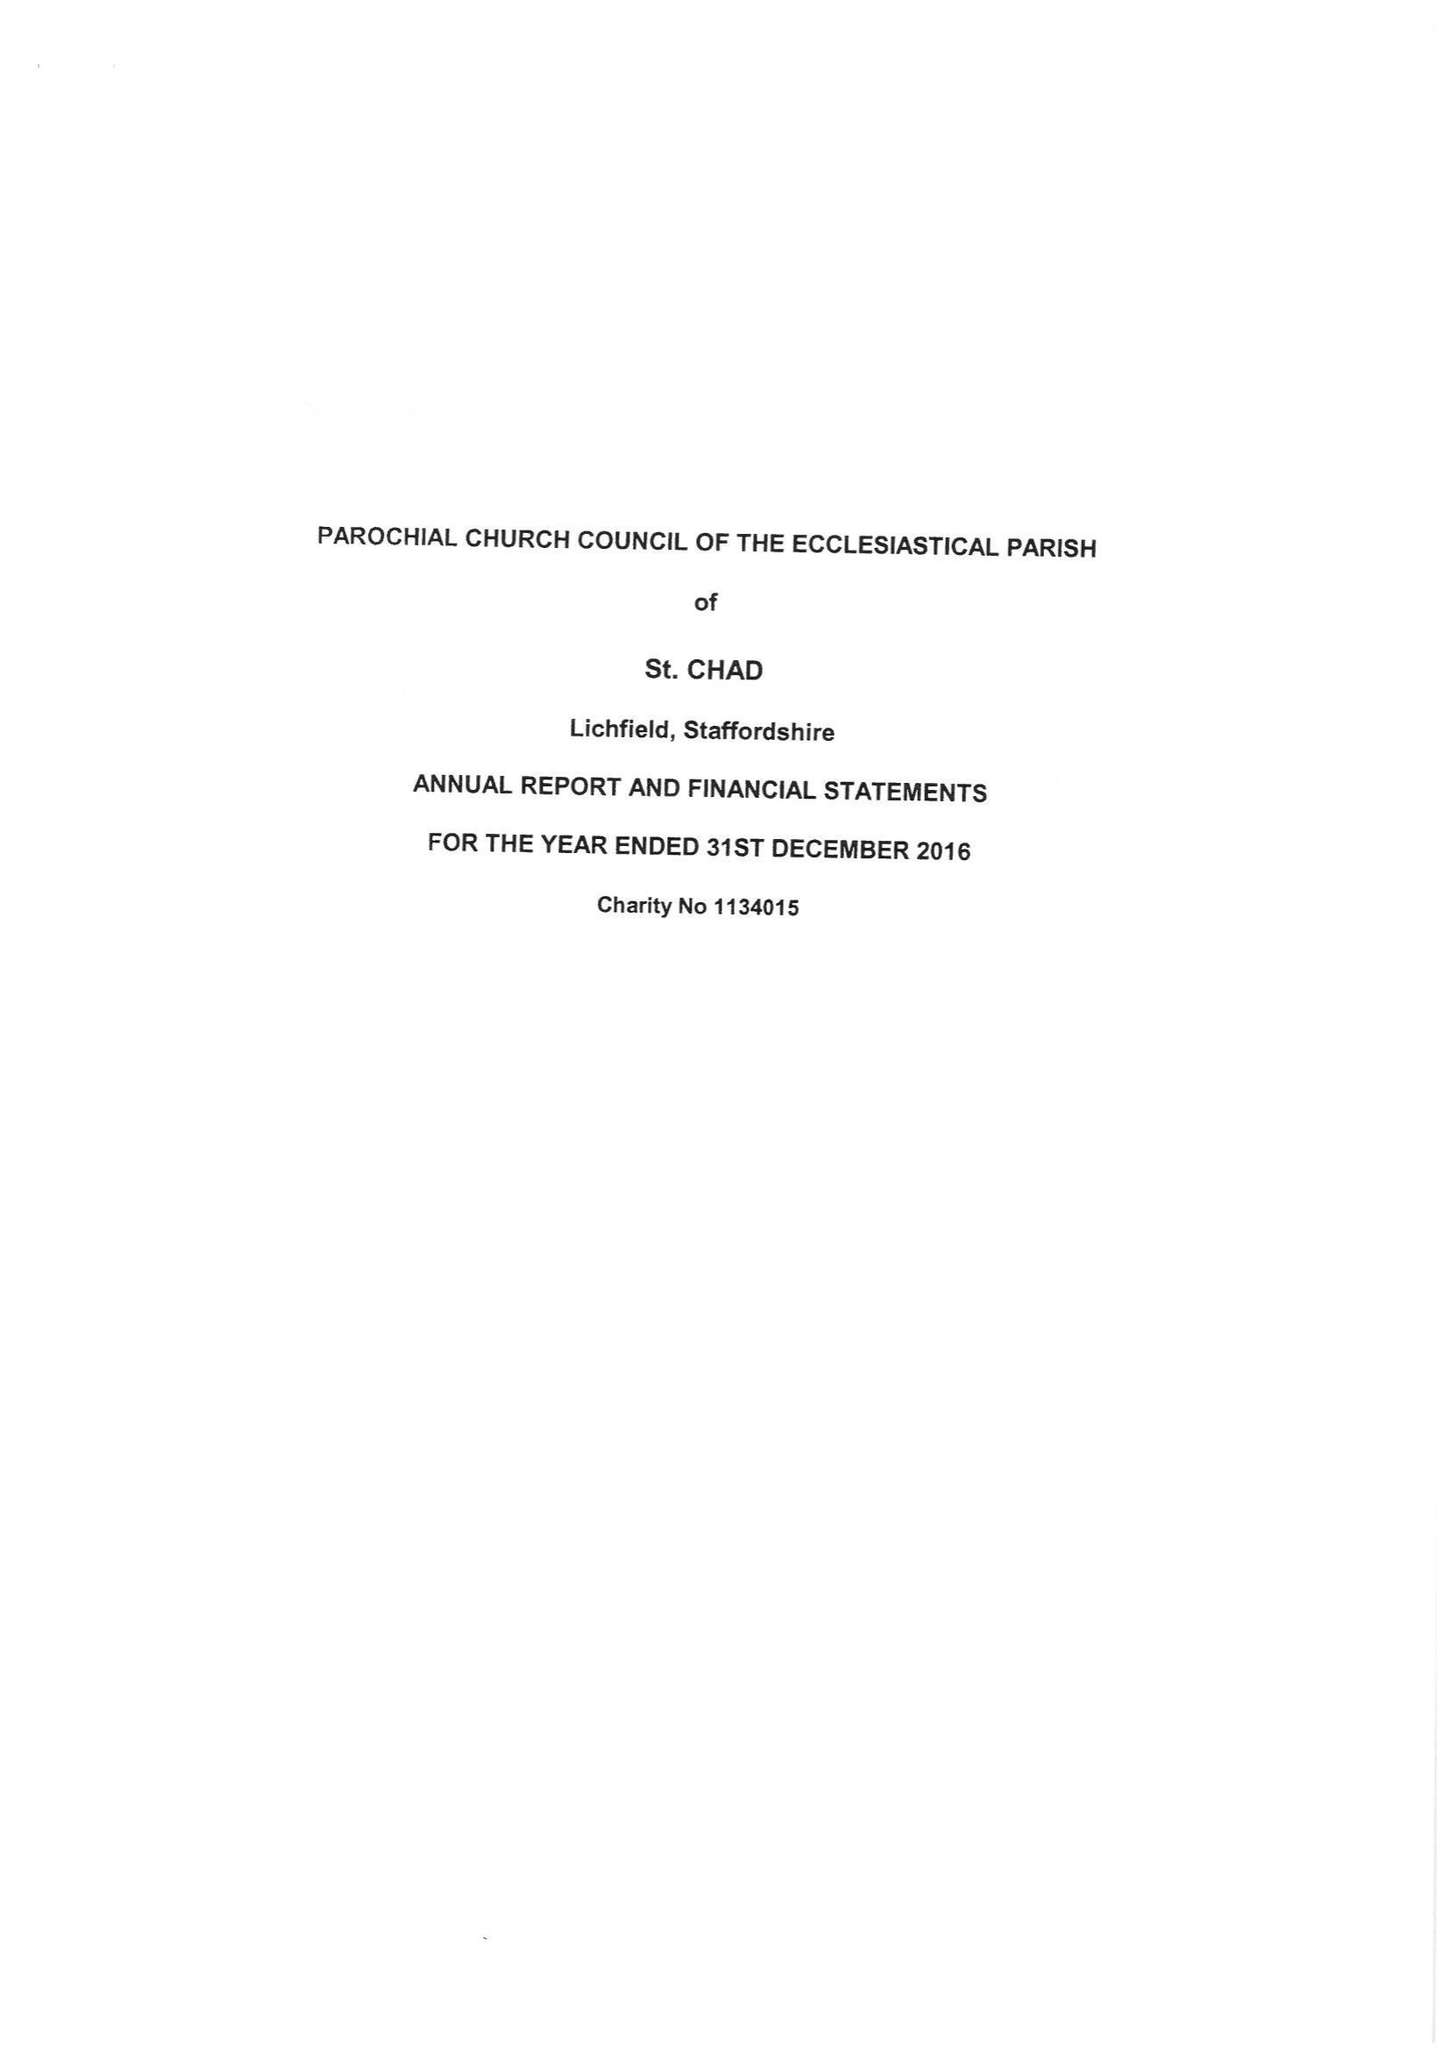What is the value for the address__street_line?
Answer the question using a single word or phrase. 42 ST CHAD'S ROAD 